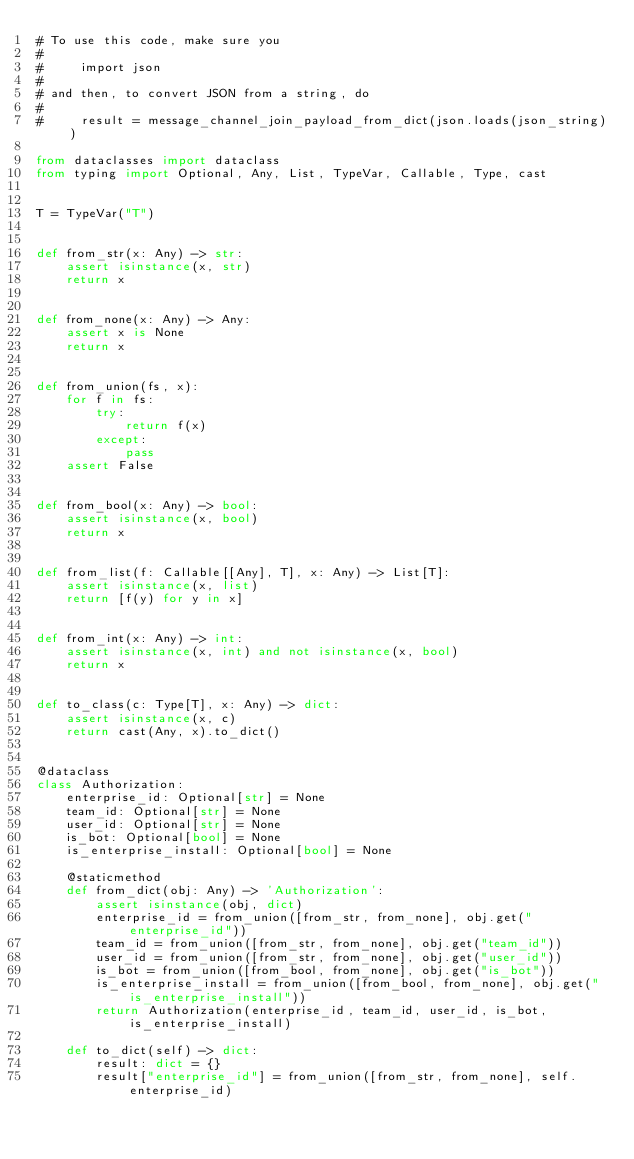Convert code to text. <code><loc_0><loc_0><loc_500><loc_500><_Python_># To use this code, make sure you
#
#     import json
#
# and then, to convert JSON from a string, do
#
#     result = message_channel_join_payload_from_dict(json.loads(json_string))

from dataclasses import dataclass
from typing import Optional, Any, List, TypeVar, Callable, Type, cast


T = TypeVar("T")


def from_str(x: Any) -> str:
    assert isinstance(x, str)
    return x


def from_none(x: Any) -> Any:
    assert x is None
    return x


def from_union(fs, x):
    for f in fs:
        try:
            return f(x)
        except:
            pass
    assert False


def from_bool(x: Any) -> bool:
    assert isinstance(x, bool)
    return x


def from_list(f: Callable[[Any], T], x: Any) -> List[T]:
    assert isinstance(x, list)
    return [f(y) for y in x]


def from_int(x: Any) -> int:
    assert isinstance(x, int) and not isinstance(x, bool)
    return x


def to_class(c: Type[T], x: Any) -> dict:
    assert isinstance(x, c)
    return cast(Any, x).to_dict()


@dataclass
class Authorization:
    enterprise_id: Optional[str] = None
    team_id: Optional[str] = None
    user_id: Optional[str] = None
    is_bot: Optional[bool] = None
    is_enterprise_install: Optional[bool] = None

    @staticmethod
    def from_dict(obj: Any) -> 'Authorization':
        assert isinstance(obj, dict)
        enterprise_id = from_union([from_str, from_none], obj.get("enterprise_id"))
        team_id = from_union([from_str, from_none], obj.get("team_id"))
        user_id = from_union([from_str, from_none], obj.get("user_id"))
        is_bot = from_union([from_bool, from_none], obj.get("is_bot"))
        is_enterprise_install = from_union([from_bool, from_none], obj.get("is_enterprise_install"))
        return Authorization(enterprise_id, team_id, user_id, is_bot, is_enterprise_install)

    def to_dict(self) -> dict:
        result: dict = {}
        result["enterprise_id"] = from_union([from_str, from_none], self.enterprise_id)</code> 